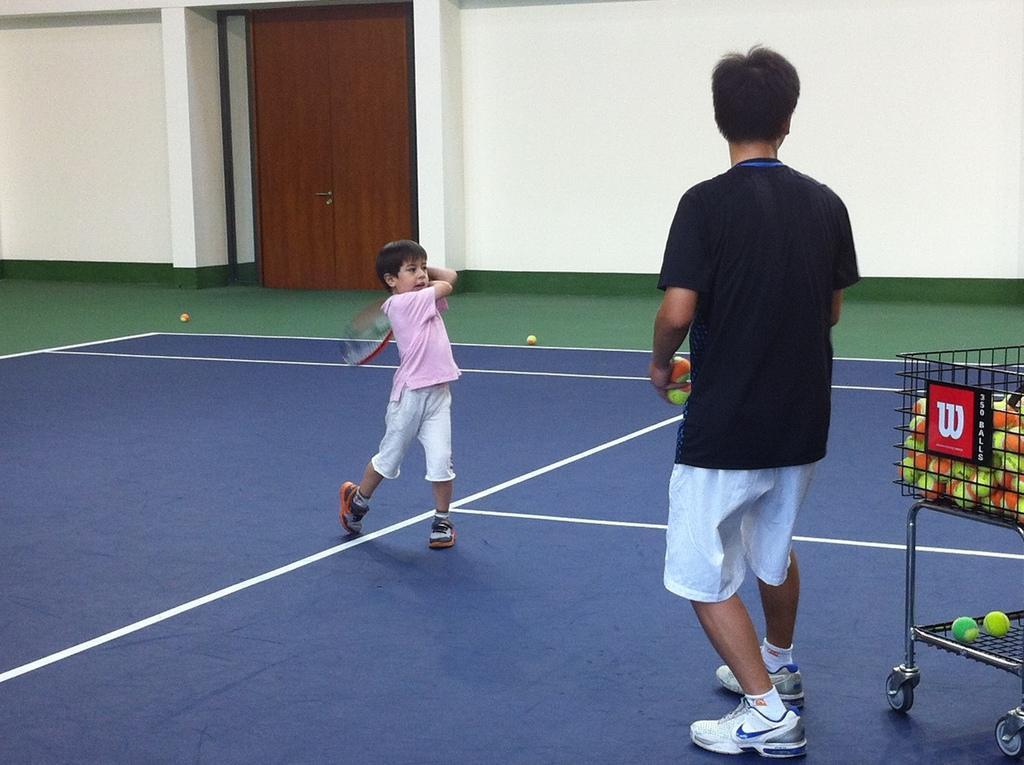Please provide a concise description of this image. This is an inside view of a room. Here I can see a man standing facing towards the back side and holding few balls in the hand. On the left side there is a boy holding a bat in the hands and standing facing towards the right side. On the right side there is trolley on which there is a basket which consists of balls. In the background there is a wall and I can see the doors. 